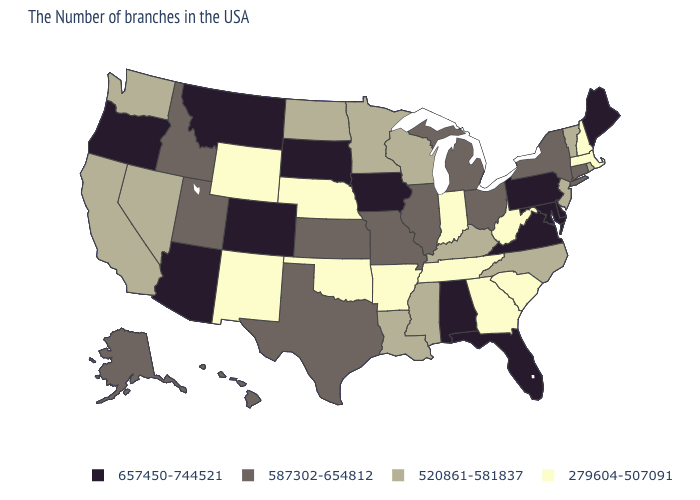Among the states that border South Carolina , does North Carolina have the lowest value?
Answer briefly. No. Which states have the highest value in the USA?
Write a very short answer. Maine, Delaware, Maryland, Pennsylvania, Virginia, Florida, Alabama, Iowa, South Dakota, Colorado, Montana, Arizona, Oregon. What is the value of Vermont?
Be succinct. 520861-581837. What is the highest value in the South ?
Quick response, please. 657450-744521. Name the states that have a value in the range 657450-744521?
Concise answer only. Maine, Delaware, Maryland, Pennsylvania, Virginia, Florida, Alabama, Iowa, South Dakota, Colorado, Montana, Arizona, Oregon. Which states have the highest value in the USA?
Quick response, please. Maine, Delaware, Maryland, Pennsylvania, Virginia, Florida, Alabama, Iowa, South Dakota, Colorado, Montana, Arizona, Oregon. Does Alabama have the highest value in the South?
Give a very brief answer. Yes. What is the highest value in the Northeast ?
Keep it brief. 657450-744521. What is the highest value in the MidWest ?
Short answer required. 657450-744521. Name the states that have a value in the range 520861-581837?
Answer briefly. Rhode Island, Vermont, New Jersey, North Carolina, Kentucky, Wisconsin, Mississippi, Louisiana, Minnesota, North Dakota, Nevada, California, Washington. What is the highest value in the South ?
Be succinct. 657450-744521. Which states have the lowest value in the MidWest?
Quick response, please. Indiana, Nebraska. What is the value of Maine?
Keep it brief. 657450-744521. Which states have the lowest value in the South?
Write a very short answer. South Carolina, West Virginia, Georgia, Tennessee, Arkansas, Oklahoma. What is the value of Utah?
Short answer required. 587302-654812. 